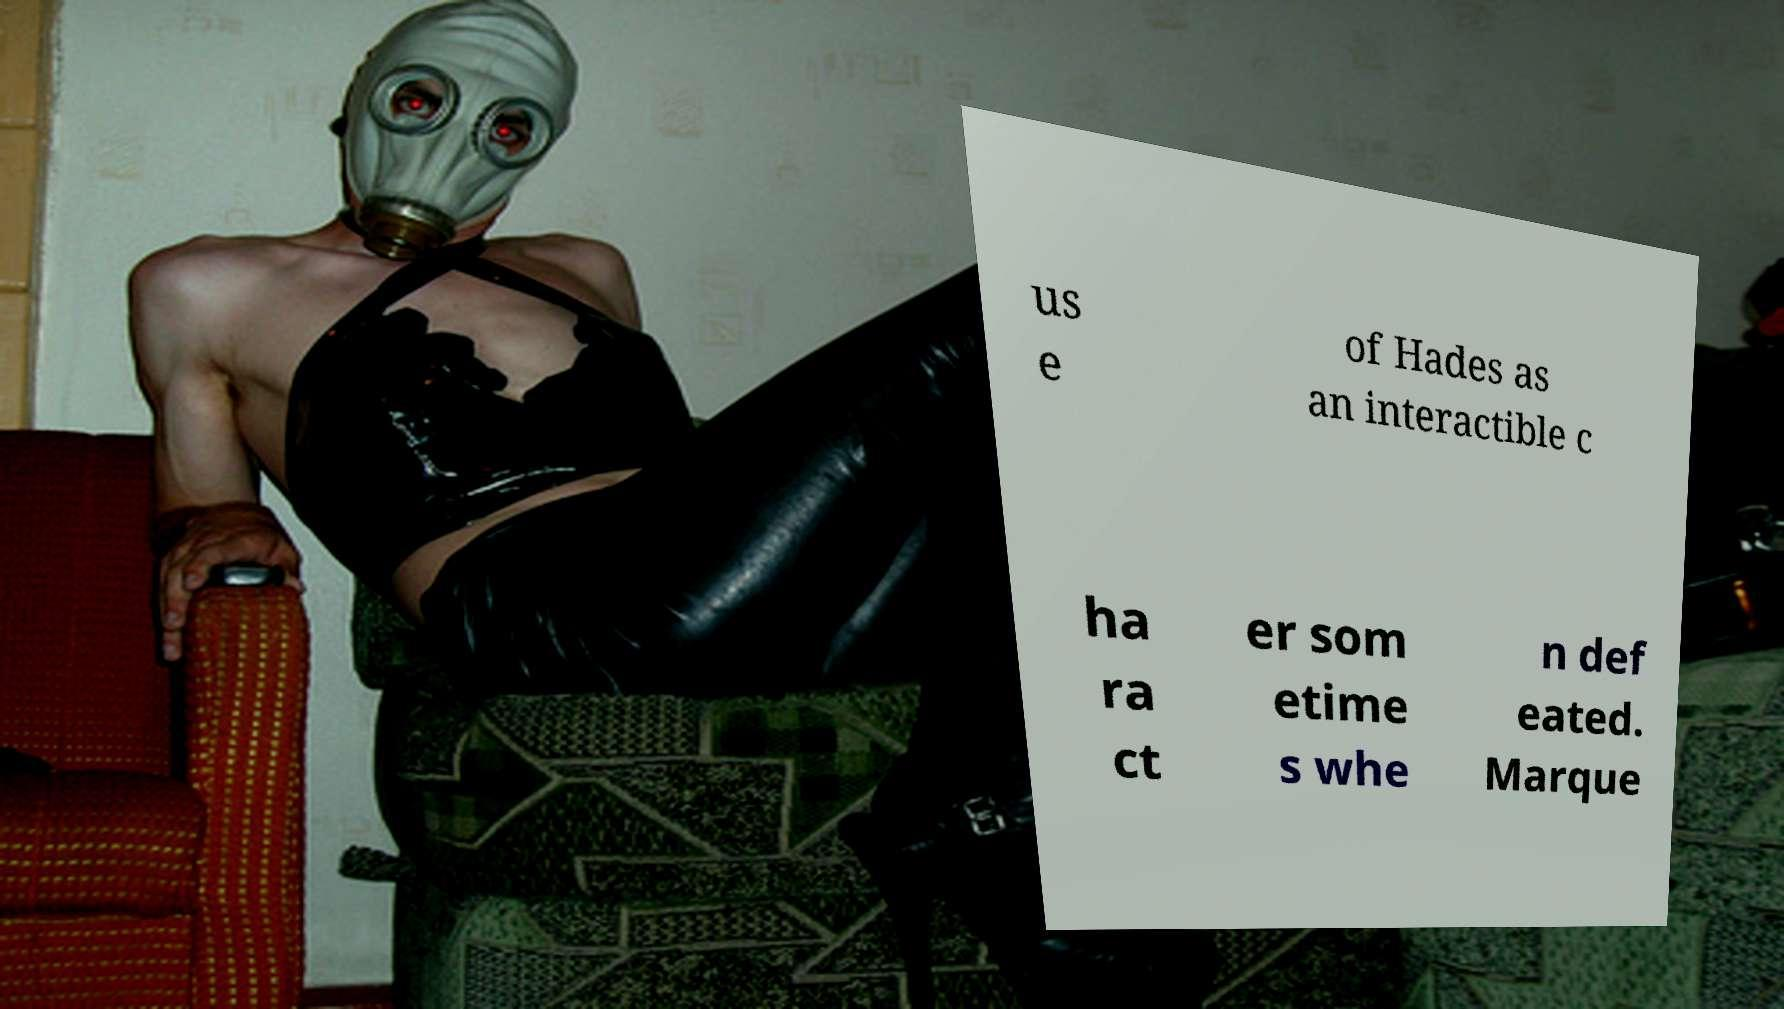There's text embedded in this image that I need extracted. Can you transcribe it verbatim? us e of Hades as an interactible c ha ra ct er som etime s whe n def eated. Marque 